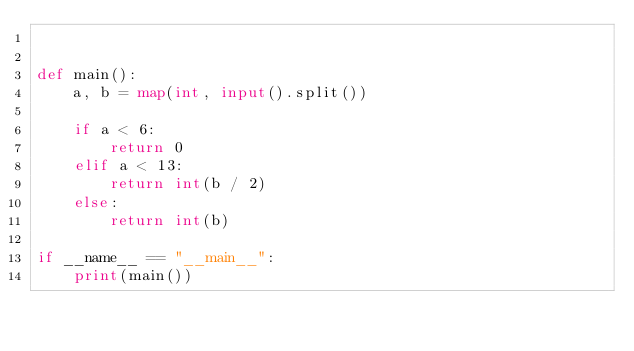Convert code to text. <code><loc_0><loc_0><loc_500><loc_500><_Python_>

def main():
    a, b = map(int, input().split())

    if a < 6:
        return 0
    elif a < 13:
        return int(b / 2)
    else:
        return int(b)

if __name__ == "__main__":
    print(main())</code> 